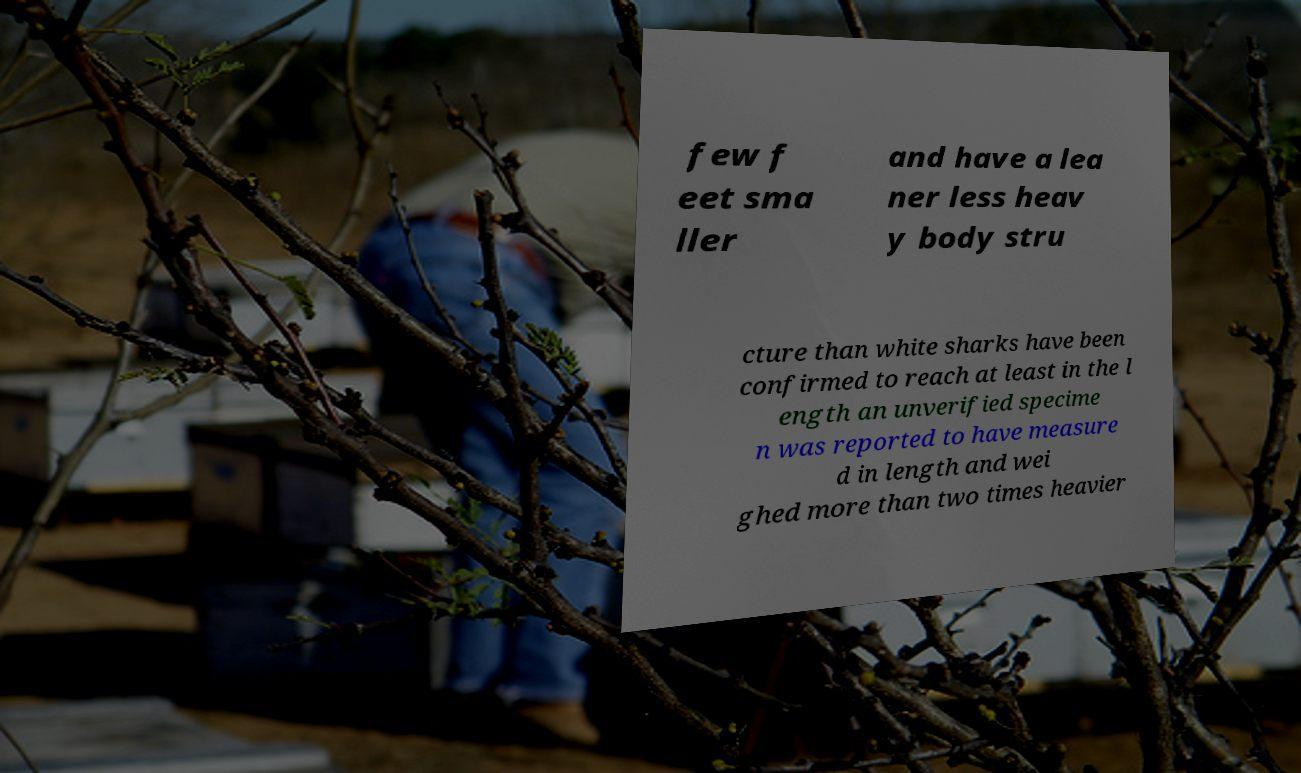Can you read and provide the text displayed in the image?This photo seems to have some interesting text. Can you extract and type it out for me? few f eet sma ller and have a lea ner less heav y body stru cture than white sharks have been confirmed to reach at least in the l ength an unverified specime n was reported to have measure d in length and wei ghed more than two times heavier 